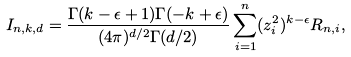Convert formula to latex. <formula><loc_0><loc_0><loc_500><loc_500>I _ { n , k , d } = \frac { \Gamma ( k - \epsilon + 1 ) \Gamma ( - k + \epsilon ) } { ( 4 \pi ) ^ { d / 2 } \Gamma ( d / 2 ) } \sum _ { i = 1 } ^ { n } ( z _ { i } ^ { 2 } ) ^ { k - \epsilon } R _ { n , i } ,</formula> 